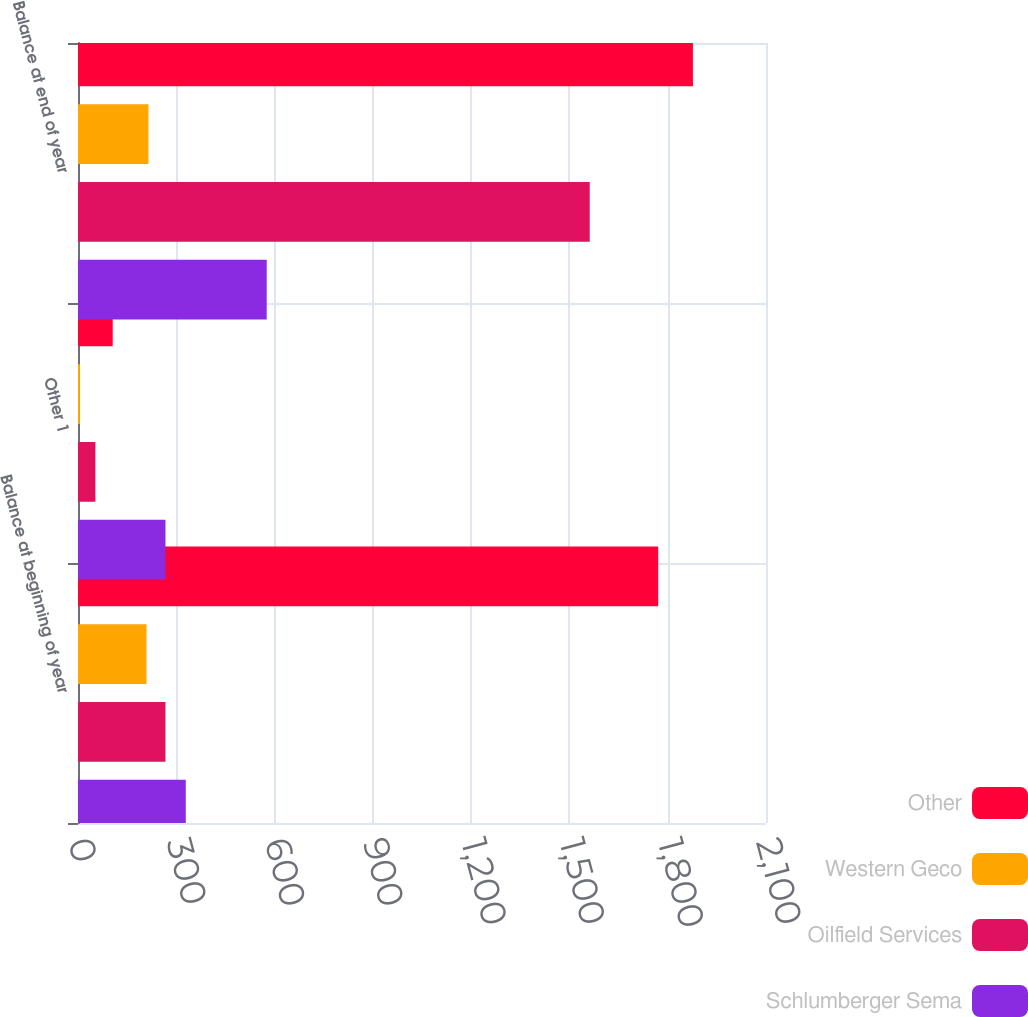Convert chart to OTSL. <chart><loc_0><loc_0><loc_500><loc_500><stacked_bar_chart><ecel><fcel>Balance at beginning of year<fcel>Other 1<fcel>Balance at end of year<nl><fcel>Other<fcel>1771<fcel>106<fcel>1877<nl><fcel>Western Geco<fcel>209<fcel>6<fcel>215<nl><fcel>Oilfield Services<fcel>267<fcel>53<fcel>1562<nl><fcel>Schlumberger Sema<fcel>329<fcel>267<fcel>576<nl></chart> 